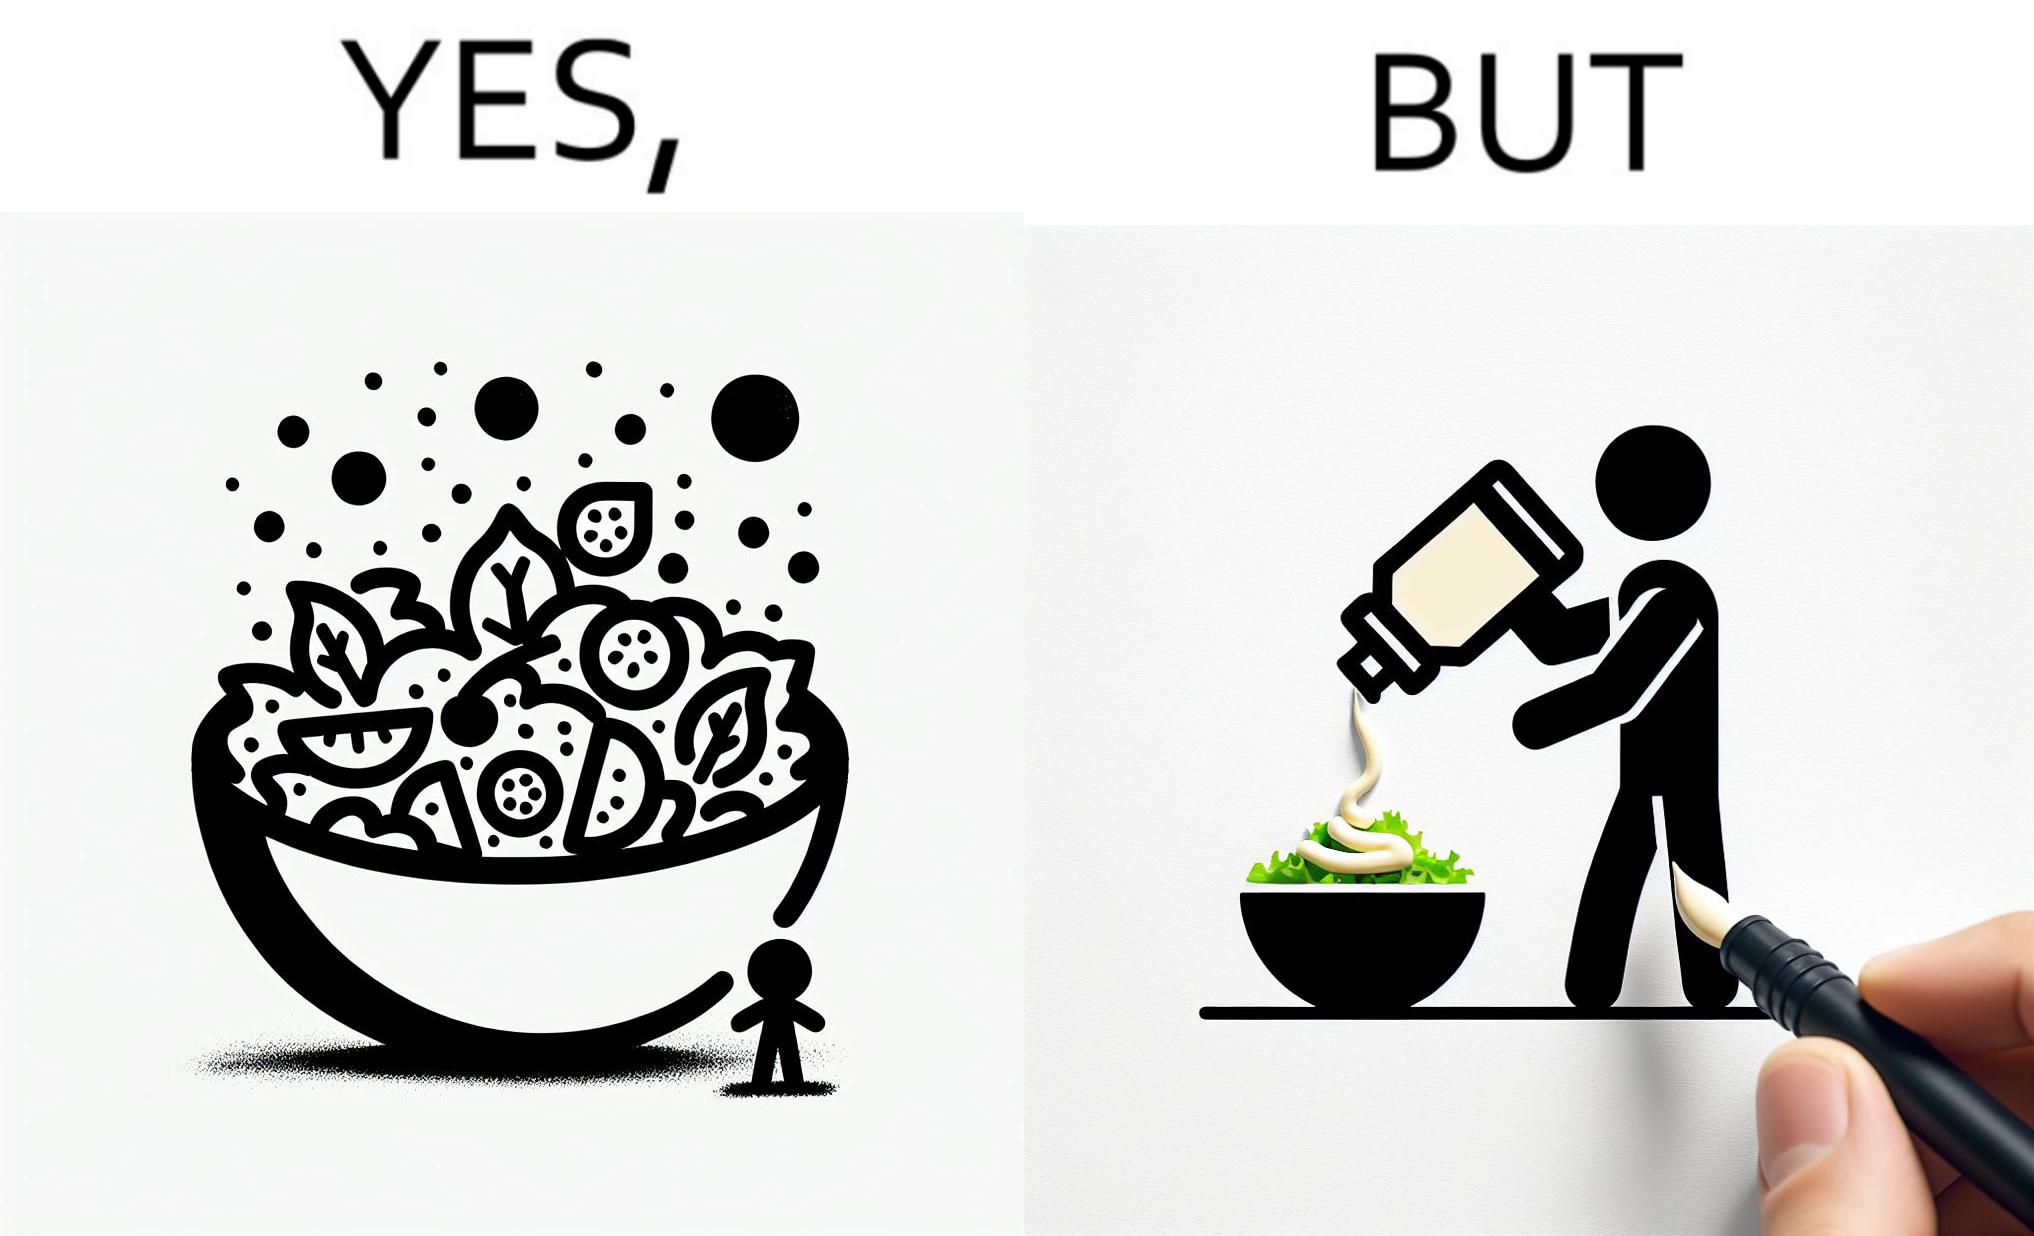Provide a description of this image. The image is ironical, as salad in a bowl by itself is very healthy. However, when people have it with Mayonnaise sauce to improve the taste, it is not healthy anymore, and defeats the point of having nutrient-rich salad altogether. 